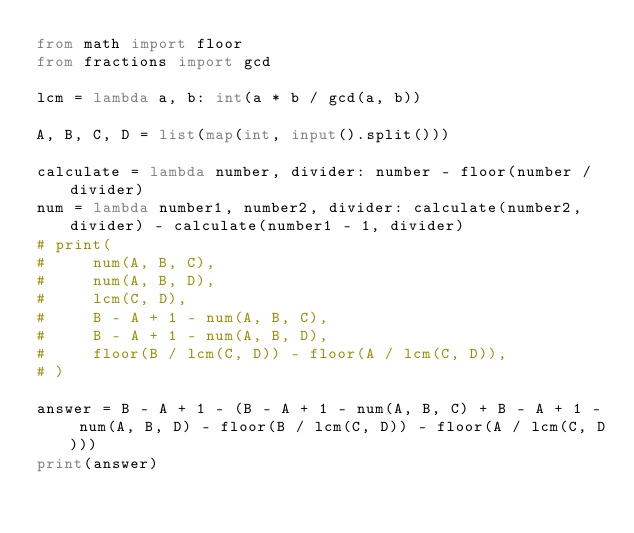Convert code to text. <code><loc_0><loc_0><loc_500><loc_500><_Python_>from math import floor
from fractions import gcd

lcm = lambda a, b: int(a * b / gcd(a, b))

A, B, C, D = list(map(int, input().split()))

calculate = lambda number, divider: number - floor(number / divider)
num = lambda number1, number2, divider: calculate(number2, divider) - calculate(number1 - 1, divider)
# print(
#     num(A, B, C),
#     num(A, B, D),
#     lcm(C, D),
#     B - A + 1 - num(A, B, C),
#     B - A + 1 - num(A, B, D),
#     floor(B / lcm(C, D)) - floor(A / lcm(C, D)),
# )

answer = B - A + 1 - (B - A + 1 - num(A, B, C) + B - A + 1 - num(A, B, D) - floor(B / lcm(C, D)) - floor(A / lcm(C, D)))
print(answer)
</code> 